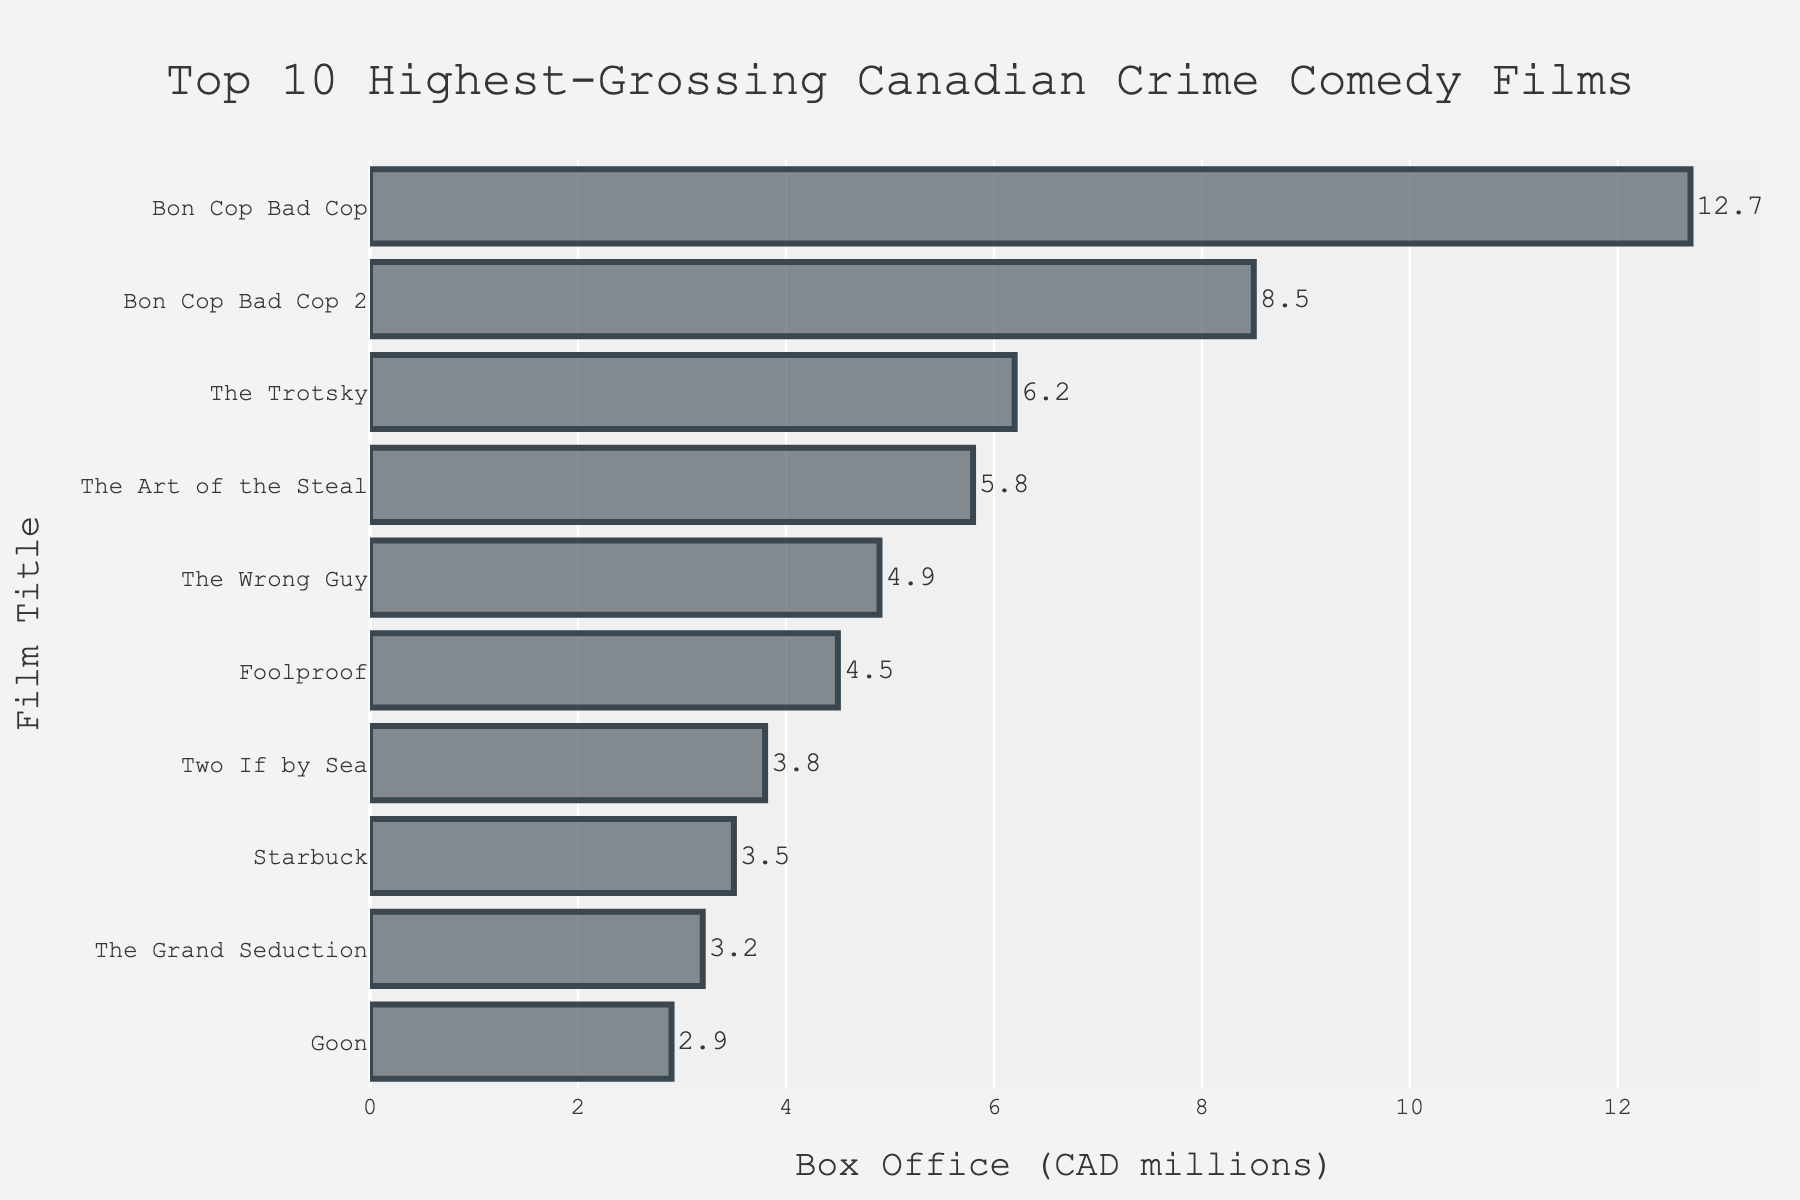What's the highest-grossing film in the list? The highest-grossing film can be identified by looking at the longest bar in the chart, which represents the top value. The longest bar corresponds to "Bon Cop Bad Cop" with a box office of 12.7 million CAD.
Answer: Bon Cop Bad Cop Which film grossed less, "Goon" or "Starbuck"? By comparing the lengths of the bars for "Goon" and "Starbuck", it is evident that the bar for "Goon" is shorter than "Starbuck". The box office for "Goon" is 2.9 million CAD, while for "Starbuck" it is 3.5 million CAD.
Answer: Goon What is the difference in box office revenue between "Bon Cop Bad Cop" and "Bon Cop Bad Cop 2"? To find the difference, subtract the box office revenue of "Bon Cop Bad Cop 2" from "Bon Cop Bad Cop". This is 12.7 million CAD - 8.5 million CAD = 4.2 million CAD.
Answer: 4.2 million CAD Which films have a box office revenue greater than 5 million CAD? Films with bars extending past the 5 million CAD mark on the x-axis are "Bon Cop Bad Cop", "Bon Cop Bad Cop 2", "The Trotsky", and "The Art of the Steal".
Answer: Bon Cop Bad Cop, Bon Cop Bad Cop 2, The Trotsky, The Art of the Steal What's the average box office revenue of the top 5 films? The top 5 films are "Bon Cop Bad Cop" (12.7), "Bon Cop Bad Cop 2" (8.5), "The Trotsky" (6.2), "The Art of the Steal" (5.8), and "The Wrong Guy" (4.9). Their total is 12.7 + 8.5 + 6.2 + 5.8 + 4.9 = 38.1. The average is 38.1 / 5 = 7.62.
Answer: 7.62 million CAD How many films have a box office revenue less than 4 million CAD? Films with bars that do not reach the 4 million CAD mark on the x-axis are "Two If by Sea", "Starbuck", "The Grand Seduction", and "Goon". That's 4 films.
Answer: 4 What is the total box office revenue of all films in the list? Sum the box office revenues of all the films: 12.7 + 8.5 + 6.2 + 5.8 + 4.9 + 4.5 + 3.8 + 3.5 + 3.2 + 2.9 = 56 million CAD.
Answer: 56 million CAD Which film earned the least? The film with the shortest bar on the chart is "Goon", with a box office revenue of 2.9 million CAD.
Answer: Goon Are there more films with a box office of over 5 million CAD or under 5 million CAD? Count the films with box office revenues over 5 million CAD (4: "Bon Cop Bad Cop", "Bon Cop Bad Cop 2", "The Trotsky", "The Art of the Steal") and under 5 million CAD (6: "The Wrong Guy", "Foolproof", "Two If by Sea", "Starbuck", "The Grand Seduction", "Goon").
Answer: Under 5 million CAD 